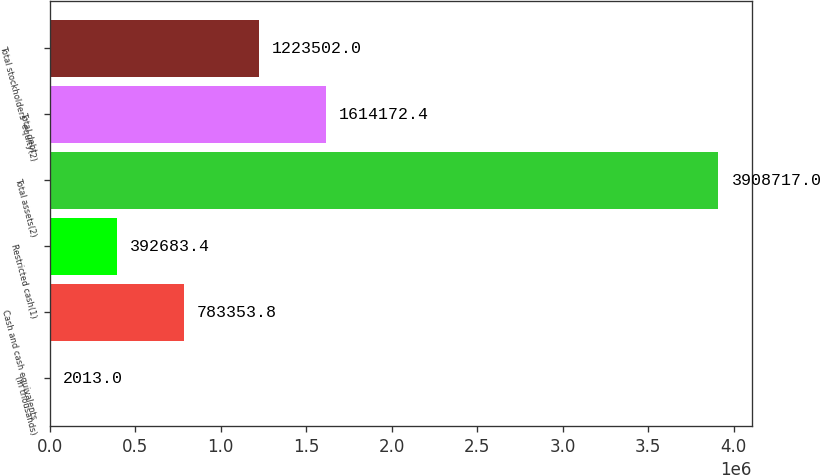Convert chart to OTSL. <chart><loc_0><loc_0><loc_500><loc_500><bar_chart><fcel>(in thousands)<fcel>Cash and cash equivalents<fcel>Restricted cash(1)<fcel>Total assets(2)<fcel>Total debt<fcel>Total stockholders' equity(2)<nl><fcel>2013<fcel>783354<fcel>392683<fcel>3.90872e+06<fcel>1.61417e+06<fcel>1.2235e+06<nl></chart> 